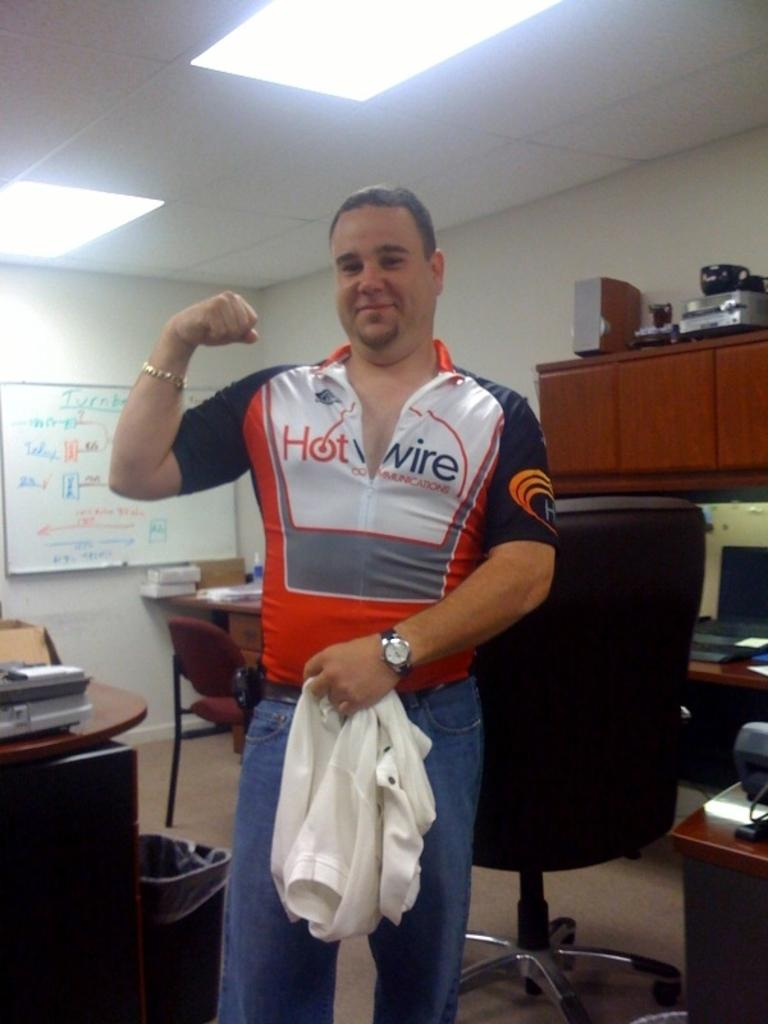Provide a one-sentence caption for the provided image. A man with a Hot Wire shirt on. 